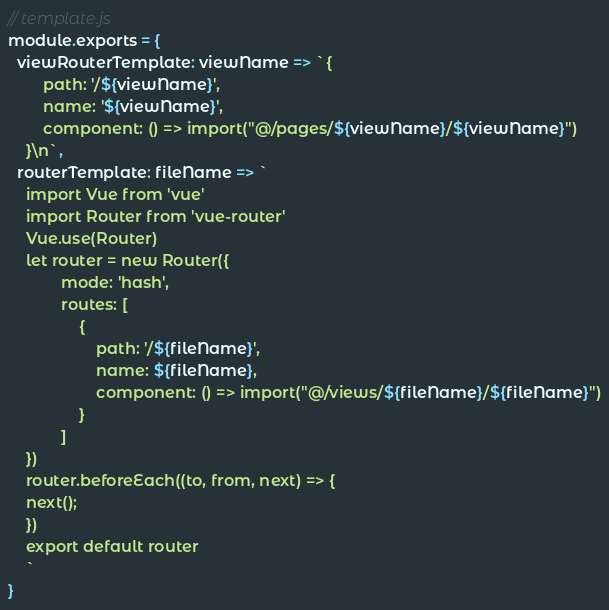<code> <loc_0><loc_0><loc_500><loc_500><_JavaScript_>// template.js
module.exports = {
  viewRouterTemplate: viewName => `{
        path: '/${viewName}',
        name: '${viewName}',
        component: () => import("@/pages/${viewName}/${viewName}")
    }\n`,
  routerTemplate: fileName => `
    import Vue from 'vue'
    import Router from 'vue-router'
    Vue.use(Router)
    let router = new Router({
            mode: 'hash',
            routes: [
                {
                    path: '/${fileName}',
                    name: ${fileName},
                    component: () => import("@/views/${fileName}/${fileName}")
                }
            ]
    })
    router.beforeEach((to, from, next) => {
    next();
    })
    export default router
    `
}
</code> 